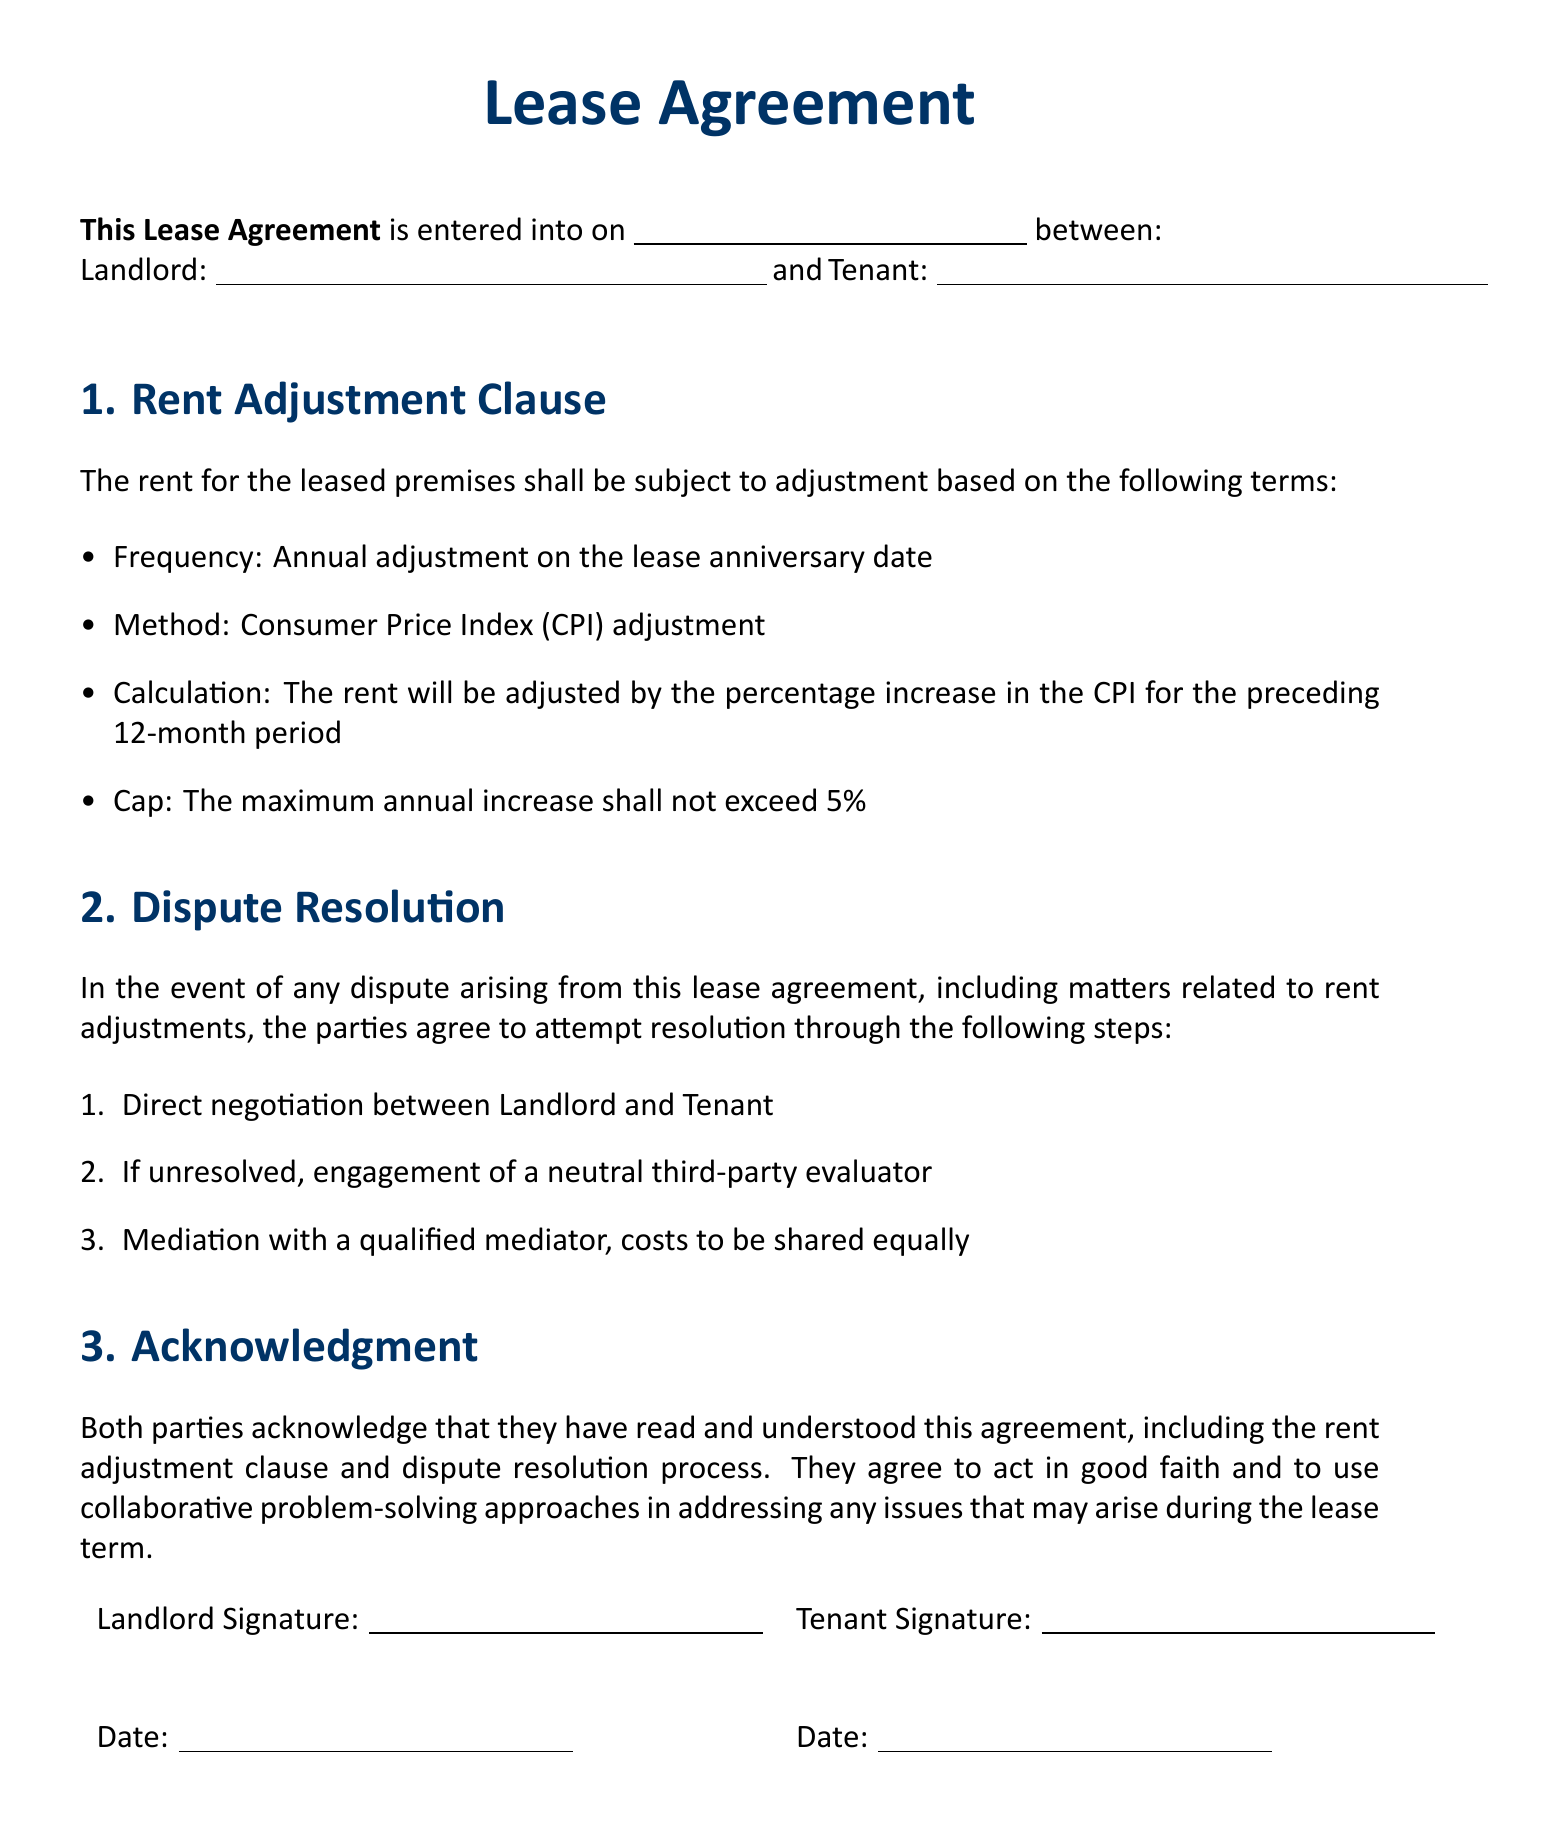What is the frequency of rent adjustments? The document states that rent adjustments occur on an annual basis on the lease anniversary date.
Answer: Annual What is the method for calculating rent adjustments? The document specifies that the rent will be adjusted based on the Consumer Price Index (CPI).
Answer: CPI What is the maximum percentage for rent increase? According to the lease agreement, the maximum annual increase shall not exceed five percent.
Answer: 5% What is the first step in the dispute resolution process? The document outlines that direct negotiation between the Landlord and Tenant is the first step for resolving disputes.
Answer: Negotiation Who shares the costs of mediation? The lease agreement indicates that the costs of mediation are to be shared equally between the parties.
Answer: Equally What do both parties acknowledge in the lease agreement? The parties acknowledge that they have read and understood the agreement, including the rent adjustment clause and dispute resolution process.
Answer: Read and understood What is the role of a neutral third-party evaluator in dispute resolution? The document states that if unresolved, the parties will engage a neutral third-party evaluator to assist in resolving disputes.
Answer: Engage evaluator On which date is the lease agreement entered into? The specific date of entering the lease agreement is to be filled in and is indicated as a blank space in the document.
Answer: \_\_\_\_\_\_ What are the signatures required in the document? The Lease Agreement requires the signatures of both the Landlord and the Tenant along with dates.
Answer: Landlord and Tenant signatures 